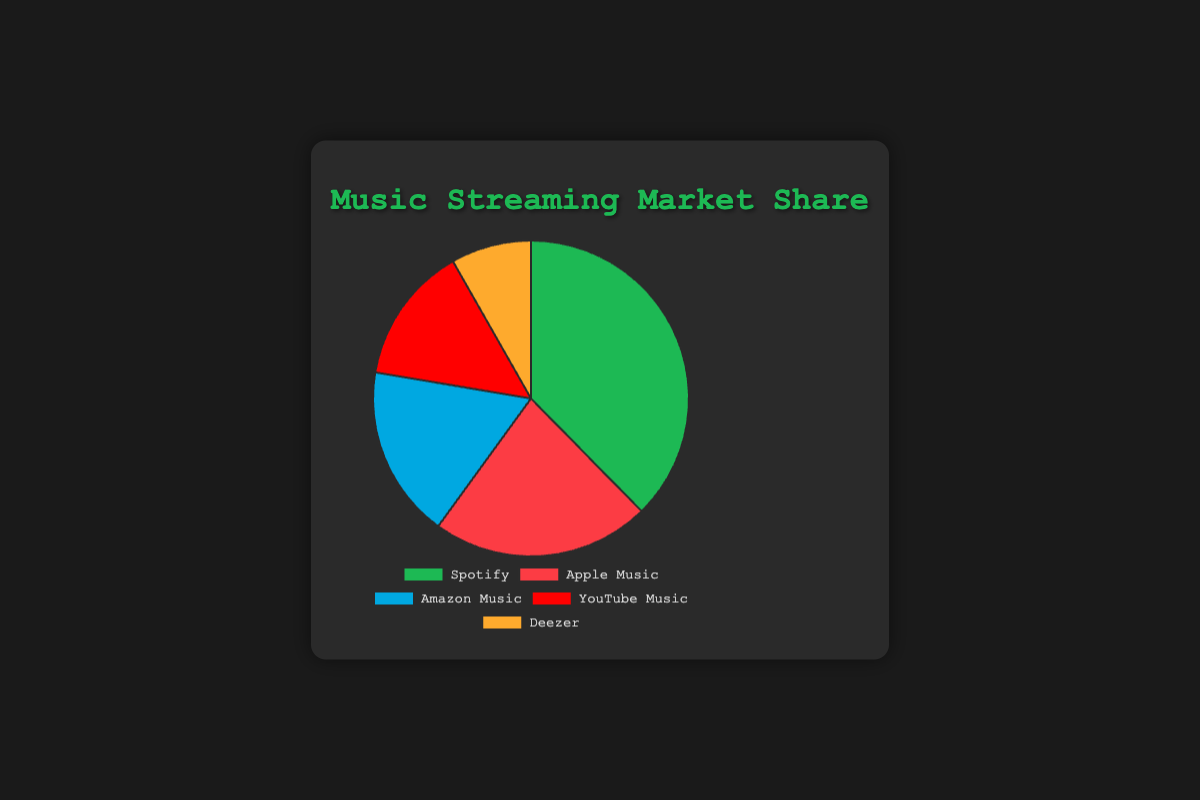What percentage of the market does Spotify hold? The section representing Spotify shows a market share percentage of 32%.
Answer: 32% Which platform has the smallest market share? By observing the pie chart, Deezer has the smallest section, with a market share of 7%.
Answer: Deezer What is the combined market share of Apple Music and Amazon Music? Apple Music has a market share of 19%, and Amazon Music has a market share of 15%. Adding these together gives 19% + 15% = 34%.
Answer: 34% How much larger is Spotify's market share compared to YouTube Music's? Spotify has a market share of 32%, and YouTube Music has 12%. Subtracting these values gives 32% - 12% = 20%.
Answer: 20% What is the average market share of all five platforms? The total market share is 32% (Spotify) + 19% (Apple Music) + 15% (Amazon Music) + 12% (YouTube Music) + 7% (Deezer) = 85%. The average market share is 85% / 5 = 17%.
Answer: 17% Which platform has a market share closest to the average market share? The average market share is 17%. The market share percentages are: Spotify (32%), Apple Music (19%), Amazon Music (15%), YouTube Music (12%), Deezer (7%). The platform closest to 17% is Amazon Music with 15%.
Answer: Amazon Music Which two platforms combined make up more than half of the market? Checking combinations, Spotify (32%) + Apple Music (19%) = 51%, which is more than half, while other combinations are less or equal 50%. Therefore, Spotify and Apple Music combined make up more than half of the market.
Answer: Spotify and Apple Music What color represents the platform with the second highest market share? Apple Music has the second highest market share at 19%, and it is represented by red in the chart.
Answer: Red How much of the market is not controlled by the top three platforms? Spotify (32%), Apple Music (19%), and Amazon Music (15%) are the top three, summing up to 32% + 19% + 15% = 66%. Therefore, the remaining market is 100% - 66% = 34%.
Answer: 34% Which platform has a market share that is less than half of Spotify's but more than Deezer's? Spotify has 32%, Deezer has 7%. Platforms less than 16% (half of Spotify) and more than 7%: Apple Music at 19% is more than 16%, and Amazon Music at 15% fits, so the platform is Amazon Music.
Answer: Amazon Music 